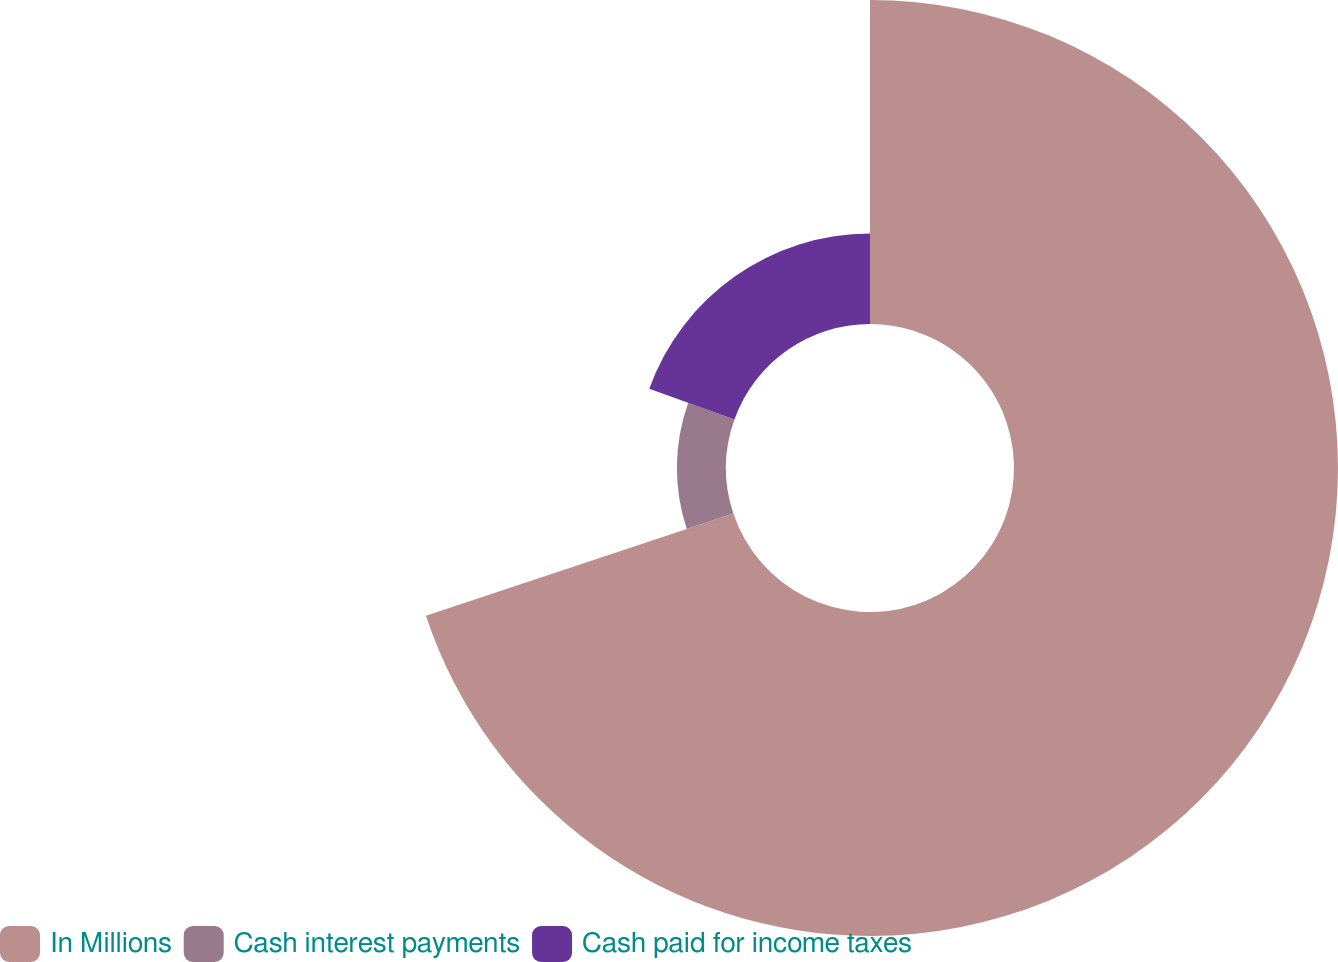Convert chart to OTSL. <chart><loc_0><loc_0><loc_500><loc_500><pie_chart><fcel>In Millions<fcel>Cash interest payments<fcel>Cash paid for income taxes<nl><fcel>69.89%<fcel>10.59%<fcel>19.52%<nl></chart> 